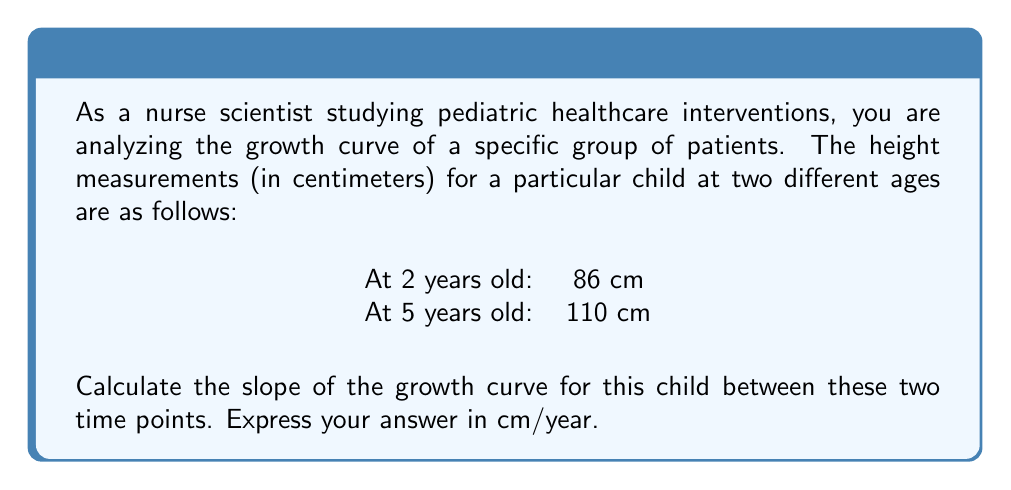Solve this math problem. To calculate the slope of the growth curve, we need to use the slope formula:

$$ \text{Slope} = \frac{\text{Change in y}}{\text{Change in x}} = \frac{\Delta y}{\Delta x} $$

In this case:
- y represents the height (in cm)
- x represents the age (in years)

Let's identify our points:
- Point 1: (2 years, 86 cm)
- Point 2: (5 years, 110 cm)

Now, let's calculate the change in y (height) and x (age):

$$ \Delta y = 110 \text{ cm} - 86 \text{ cm} = 24 \text{ cm} $$
$$ \Delta x = 5 \text{ years} - 2 \text{ years} = 3 \text{ years} $$

Plugging these values into our slope formula:

$$ \text{Slope} = \frac{\Delta y}{\Delta x} = \frac{24 \text{ cm}}{3 \text{ years}} = 8 \text{ cm/year} $$

This slope represents the average rate of growth for this child between the ages of 2 and 5 years.
Answer: $8 \text{ cm/year}$ 